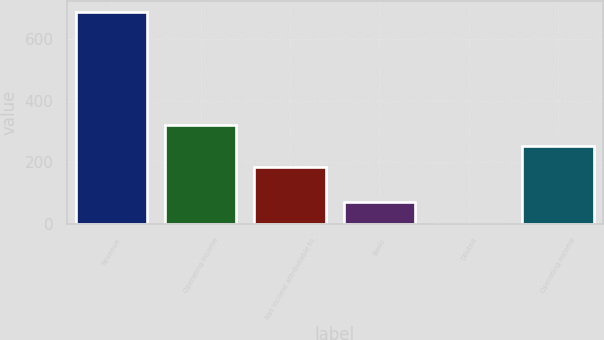Convert chart. <chart><loc_0><loc_0><loc_500><loc_500><bar_chart><fcel>Revenue<fcel>Operating Income<fcel>Net income attributable to<fcel>Basic<fcel>Diluted<fcel>Operating income<nl><fcel>688.5<fcel>321.44<fcel>183.9<fcel>69.58<fcel>0.81<fcel>252.67<nl></chart> 